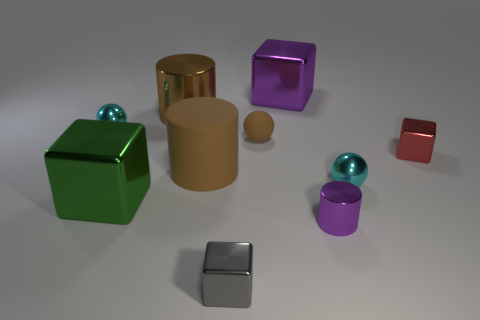Subtract all purple cubes. How many cubes are left? 3 Subtract all purple blocks. How many blocks are left? 3 Subtract 2 blocks. How many blocks are left? 2 Subtract all cyan cubes. Subtract all yellow balls. How many cubes are left? 4 Subtract 1 green cubes. How many objects are left? 9 Subtract all cubes. How many objects are left? 6 Subtract all purple metallic things. Subtract all gray cubes. How many objects are left? 7 Add 2 big purple cubes. How many big purple cubes are left? 3 Add 5 purple cylinders. How many purple cylinders exist? 6 